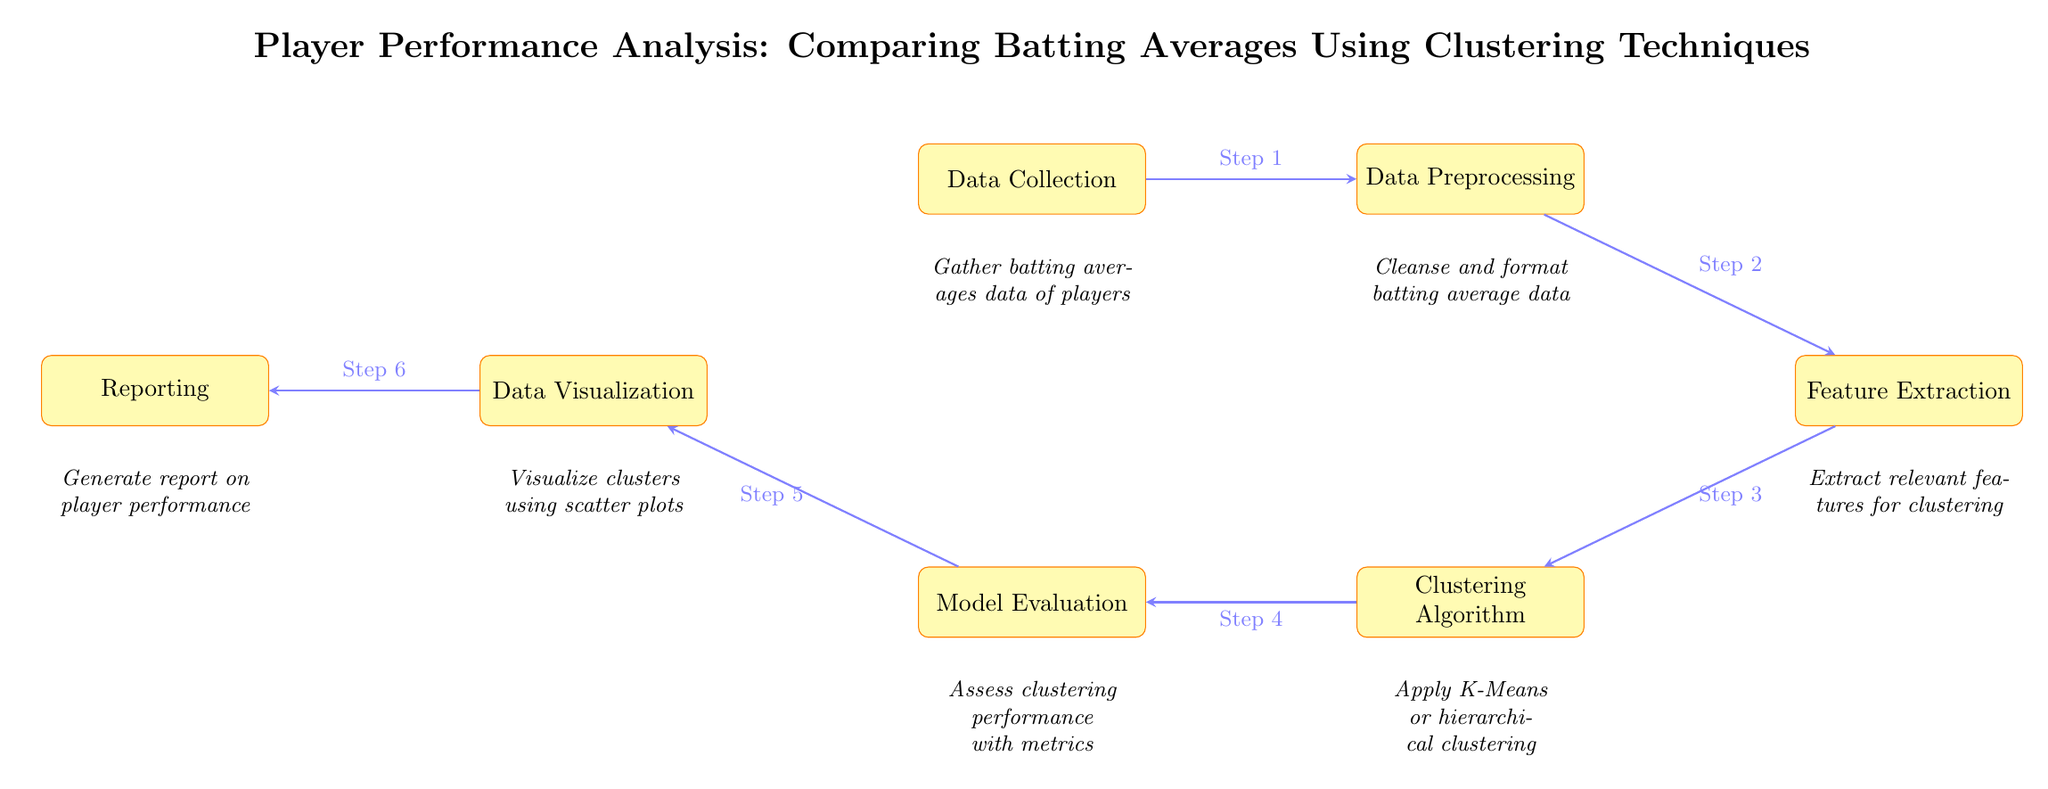What is the first step in the diagram? The diagram identifies "Data Collection" as the first process, which is positioned at the top left. It is labeled as Step 1 in the flow.
Answer: Data Collection How many processes are in the diagram? By counting the distinct processes represented in rectangles, we see that there are a total of seven, including Data Collection and Reporting.
Answer: Seven What comes after Data Preprocessing? According to the flow of the diagram, the next step after Data Preprocessing is Feature Extraction, which is directly connected by an arrow labeled Step 2.
Answer: Feature Extraction What is the last step in the analysis process? The final process shown in the diagram, after all previous steps, is Reporting, positioned at the far left. This is indicated as Step 6.
Answer: Reporting Which clustering technique is mentioned in the diagram? The diagram specifies the use of either K-Means or hierarchical clustering within the Clustering Algorithm process. This can be seen in the text next to the corresponding rectangle.
Answer: K-Means or hierarchical clustering What does the evaluation step assess? The Evaluation process evaluates clustering performance using various metrics, as indicated in the explanatory text below the Evaluation node.
Answer: Clustering performance Which process involves visual representation of the data? The process responsible for visualizing clusters through scatter plots is Data Visualization, which is the fifth step in the flow of the diagram.
Answer: Data Visualization What is the relationship between Clustering Algorithm and Model Evaluation? The Clustering Algorithm process flows directly into the Model Evaluation process, illustrating that clustering results must be assessed before visualization can occur, indicated by a connecting arrow.
Answer: Sequential relationship 